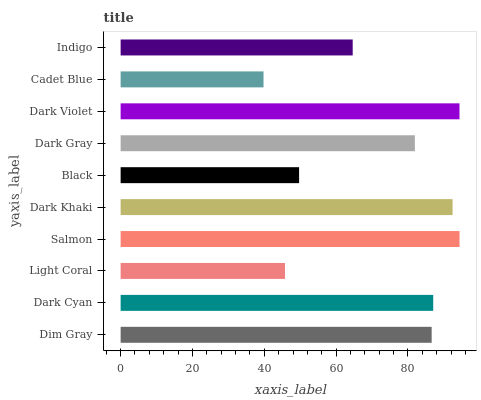Is Cadet Blue the minimum?
Answer yes or no. Yes. Is Salmon the maximum?
Answer yes or no. Yes. Is Dark Cyan the minimum?
Answer yes or no. No. Is Dark Cyan the maximum?
Answer yes or no. No. Is Dark Cyan greater than Dim Gray?
Answer yes or no. Yes. Is Dim Gray less than Dark Cyan?
Answer yes or no. Yes. Is Dim Gray greater than Dark Cyan?
Answer yes or no. No. Is Dark Cyan less than Dim Gray?
Answer yes or no. No. Is Dim Gray the high median?
Answer yes or no. Yes. Is Dark Gray the low median?
Answer yes or no. Yes. Is Dark Cyan the high median?
Answer yes or no. No. Is Black the low median?
Answer yes or no. No. 